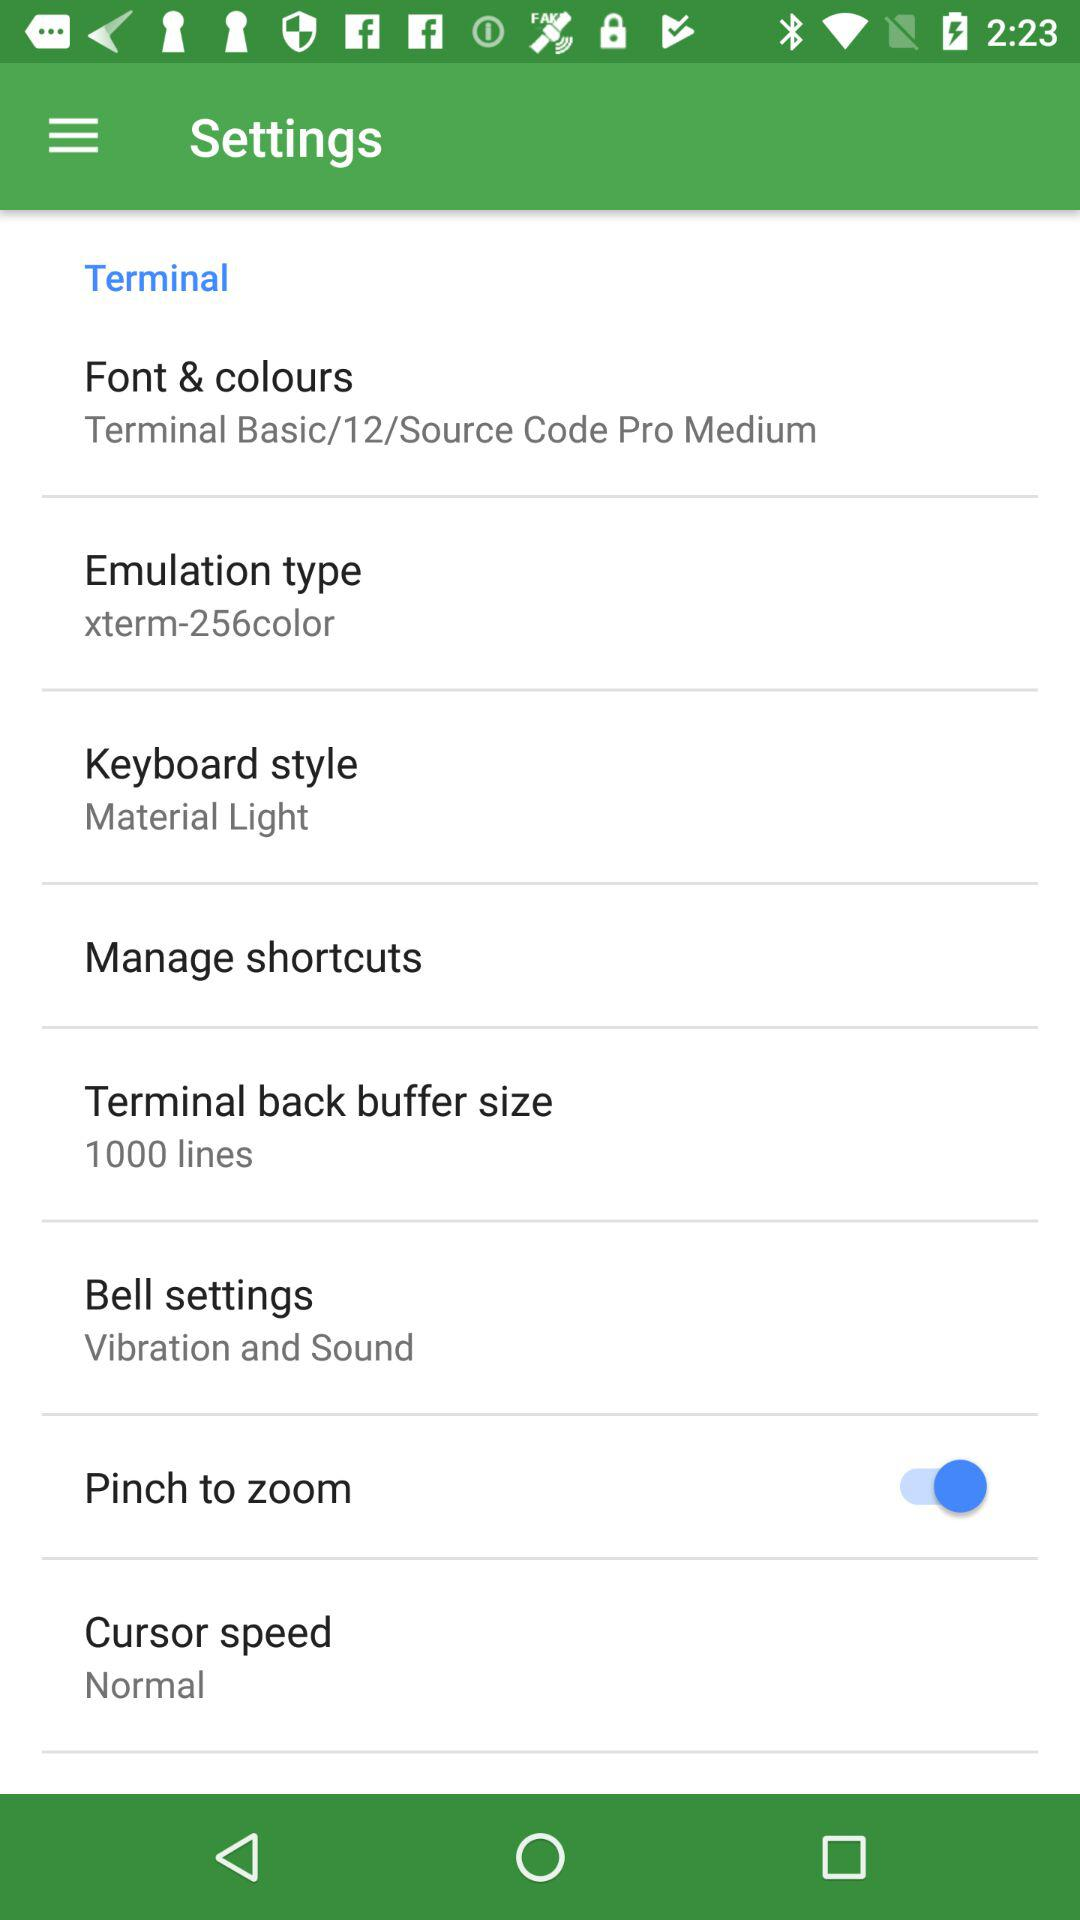Which option is selected in "Font & colours"? The selected option is "Terminal Basic/12/Source Code Pro Medium". 